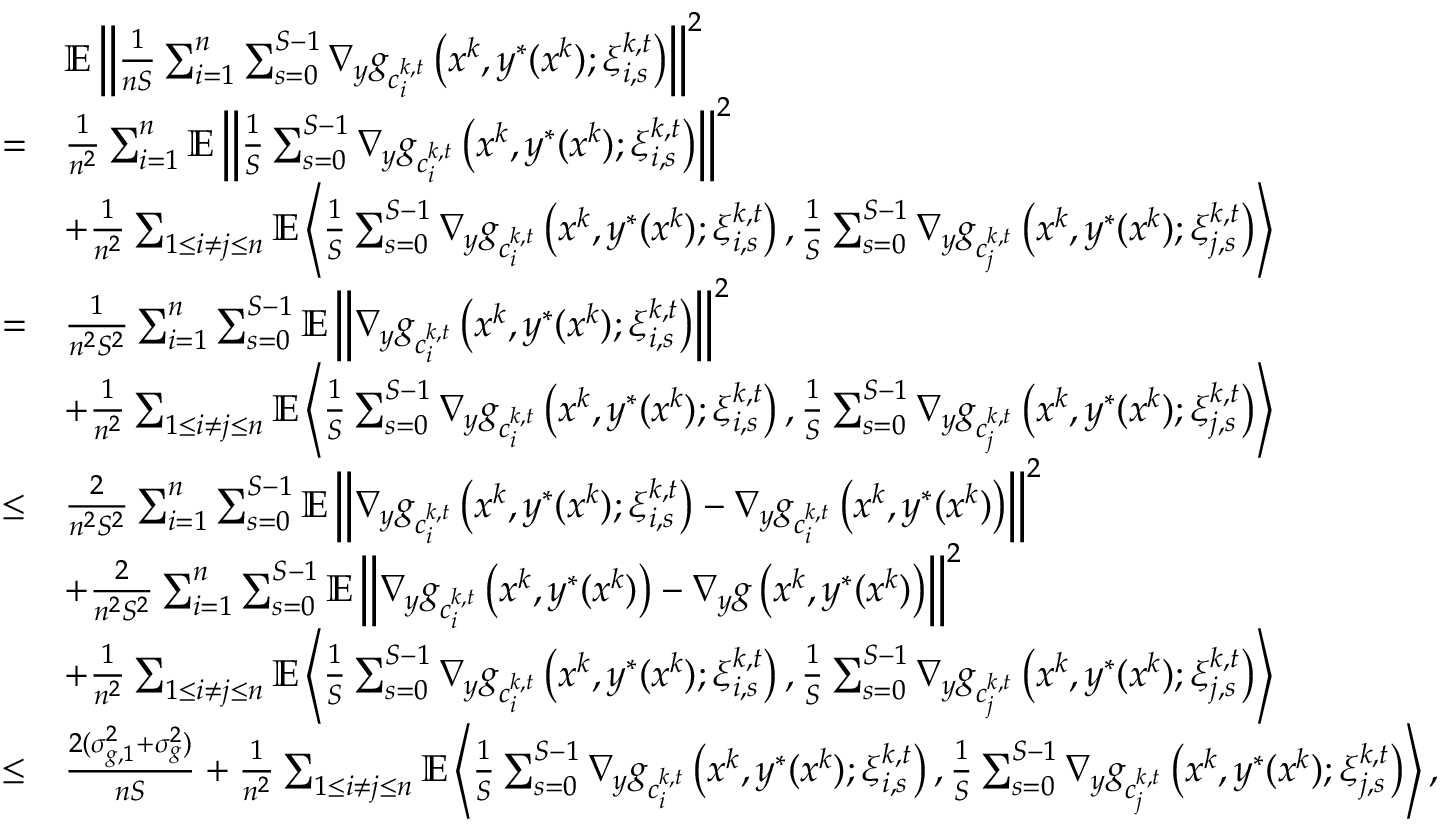<formula> <loc_0><loc_0><loc_500><loc_500>\begin{array} { r l } & { \mathbb { E } \left \| \frac { 1 } { n S } \sum _ { i = 1 } ^ { n } \sum _ { s = 0 } ^ { S - 1 } \nabla _ { y } g _ { c _ { i } ^ { k , t } } \left ( x ^ { k } , y ^ { * } ( x ^ { k } ) ; \xi _ { i , s } ^ { k , t } \right ) \right \| ^ { 2 } } \\ { = } & { \frac { 1 } { n ^ { 2 } } \sum _ { i = 1 } ^ { n } \mathbb { E } \left \| \frac { 1 } { S } \sum _ { s = 0 } ^ { S - 1 } \nabla _ { y } g _ { c _ { i } ^ { k , t } } \left ( x ^ { k } , y ^ { * } ( x ^ { k } ) ; \xi _ { i , s } ^ { k , t } \right ) \right \| ^ { 2 } } \\ & { + \frac { 1 } { n ^ { 2 } } \sum _ { 1 \leq i \neq j \leq n } \mathbb { E } \left \langle \frac { 1 } { S } \sum _ { s = 0 } ^ { S - 1 } \nabla _ { y } g _ { c _ { i } ^ { k , t } } \left ( x ^ { k } , y ^ { * } ( x ^ { k } ) ; \xi _ { i , s } ^ { k , t } \right ) , \frac { 1 } { S } \sum _ { s = 0 } ^ { S - 1 } \nabla _ { y } g _ { c _ { j } ^ { k , t } } \left ( x ^ { k } , y ^ { * } ( x ^ { k } ) ; \xi _ { j , s } ^ { k , t } \right ) \right \rangle } \\ { = } & { \frac { 1 } { n ^ { 2 } S ^ { 2 } } \sum _ { i = 1 } ^ { n } \sum _ { s = 0 } ^ { S - 1 } \mathbb { E } \left \| \nabla _ { y } g _ { c _ { i } ^ { k , t } } \left ( x ^ { k } , y ^ { * } ( x ^ { k } ) ; \xi _ { i , s } ^ { k , t } \right ) \right \| ^ { 2 } } \\ & { + \frac { 1 } { n ^ { 2 } } \sum _ { 1 \leq i \neq j \leq n } \mathbb { E } \left \langle \frac { 1 } { S } \sum _ { s = 0 } ^ { S - 1 } \nabla _ { y } g _ { c _ { i } ^ { k , t } } \left ( x ^ { k } , y ^ { * } ( x ^ { k } ) ; \xi _ { i , s } ^ { k , t } \right ) , \frac { 1 } { S } \sum _ { s = 0 } ^ { S - 1 } \nabla _ { y } g _ { c _ { j } ^ { k , t } } \left ( x ^ { k } , y ^ { * } ( x ^ { k } ) ; \xi _ { j , s } ^ { k , t } \right ) \right \rangle } \\ { \leq } & { \frac { 2 } { n ^ { 2 } S ^ { 2 } } \sum _ { i = 1 } ^ { n } \sum _ { s = 0 } ^ { S - 1 } \mathbb { E } \left \| \nabla _ { y } g _ { c _ { i } ^ { k , t } } \left ( x ^ { k } , y ^ { * } ( x ^ { k } ) ; \xi _ { i , s } ^ { k , t } \right ) - \nabla _ { y } g _ { c _ { i } ^ { k , t } } \left ( x ^ { k } , y ^ { * } ( x ^ { k } ) \right ) \right \| ^ { 2 } } \\ & { + \frac { 2 } { n ^ { 2 } S ^ { 2 } } \sum _ { i = 1 } ^ { n } \sum _ { s = 0 } ^ { S - 1 } \mathbb { E } \left \| \nabla _ { y } g _ { c _ { i } ^ { k , t } } \left ( x ^ { k } , y ^ { * } ( x ^ { k } ) \right ) - \nabla _ { y } g \left ( x ^ { k } , y ^ { * } ( x ^ { k } ) \right ) \right \| ^ { 2 } } \\ & { + \frac { 1 } { n ^ { 2 } } \sum _ { 1 \leq i \neq j \leq n } \mathbb { E } \left \langle \frac { 1 } { S } \sum _ { s = 0 } ^ { S - 1 } \nabla _ { y } g _ { c _ { i } ^ { k , t } } \left ( x ^ { k } , y ^ { * } ( x ^ { k } ) ; \xi _ { i , s } ^ { k , t } \right ) , \frac { 1 } { S } \sum _ { s = 0 } ^ { S - 1 } \nabla _ { y } g _ { c _ { j } ^ { k , t } } \left ( x ^ { k } , y ^ { * } ( x ^ { k } ) ; \xi _ { j , s } ^ { k , t } \right ) \right \rangle } \\ { \leq } & { \frac { 2 ( \sigma _ { g , 1 } ^ { 2 } + \sigma _ { g } ^ { 2 } ) } { n S } + \frac { 1 } { n ^ { 2 } } \sum _ { 1 \leq i \neq j \leq n } \mathbb { E } \left \langle \frac { 1 } { S } \sum _ { s = 0 } ^ { S - 1 } \nabla _ { y } g _ { c _ { i } ^ { k , t } } \left ( x ^ { k } , y ^ { * } ( x ^ { k } ) ; \xi _ { i , s } ^ { k , t } \right ) , \frac { 1 } { S } \sum _ { s = 0 } ^ { S - 1 } \nabla _ { y } g _ { c _ { j } ^ { k , t } } \left ( x ^ { k } , y ^ { * } ( x ^ { k } ) ; \xi _ { j , s } ^ { k , t } \right ) \right \rangle , } \end{array}</formula> 